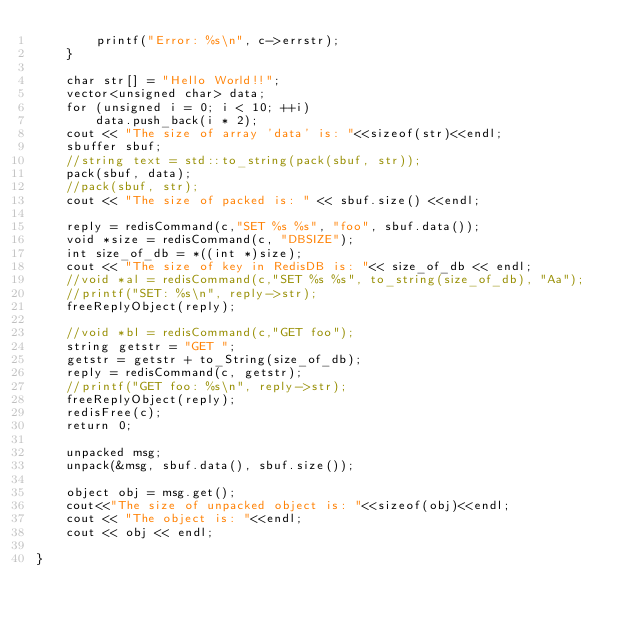Convert code to text. <code><loc_0><loc_0><loc_500><loc_500><_C++_>        printf("Error: %s\n", c->errstr);
    }

    char str[] = "Hello World!!";
    vector<unsigned char> data;
    for (unsigned i = 0; i < 10; ++i)
        data.push_back(i * 2);
    cout << "The size of array 'data' is: "<<sizeof(str)<<endl;
    sbuffer sbuf;
    //string text = std::to_string(pack(sbuf, str));
    pack(sbuf, data);
    //pack(sbuf, str);
    cout << "The size of packed is: " << sbuf.size() <<endl;

    reply = redisCommand(c,"SET %s %s", "foo", sbuf.data());
    void *size = redisCommand(c, "DBSIZE");
    int size_of_db = *((int *)size);
    cout << "The size of key in RedisDB is: "<< size_of_db << endl;
    //void *al = redisCommand(c,"SET %s %s", to_string(size_of_db), "Aa");
    //printf("SET: %s\n", reply->str);
    freeReplyObject(reply);

    //void *bl = redisCommand(c,"GET foo");
    string getstr = "GET ";
    getstr = getstr + to_String(size_of_db);
    reply = redisCommand(c, getstr);
    //printf("GET foo: %s\n", reply->str);
    freeReplyObject(reply);
    redisFree(c);
    return 0;

    unpacked msg;
    unpack(&msg, sbuf.data(), sbuf.size());

    object obj = msg.get();
    cout<<"The size of unpacked object is: "<<sizeof(obj)<<endl;
    cout << "The object is: "<<endl;
    cout << obj << endl;

}
</code> 